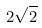<formula> <loc_0><loc_0><loc_500><loc_500>2 \sqrt { 2 }</formula> 